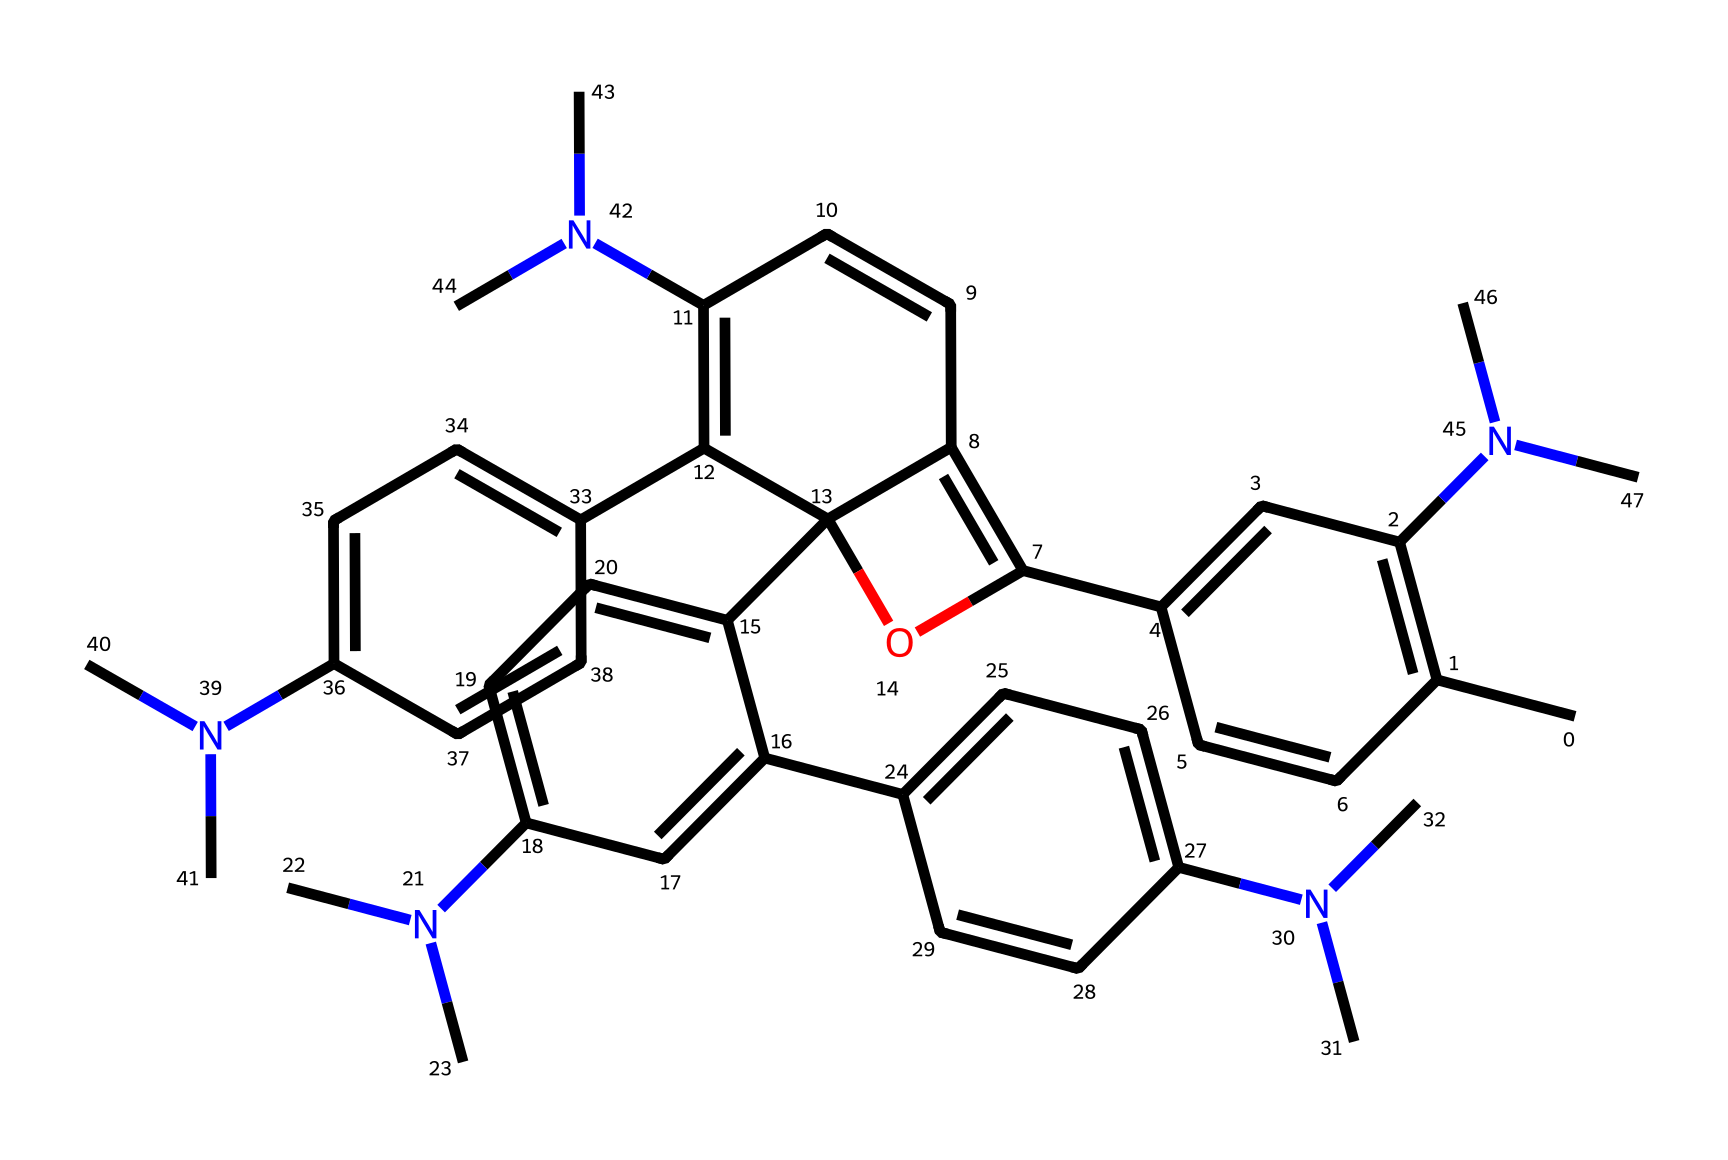What is the total number of nitrogen atoms in this compound? By examining the chemical structure, we can identify each nitrogen atom represented by the "N" symbol within the SMILES notation. In this case, by counting, we find that there are a total of six "N" present.
Answer: six What type of structure is primarily indicated by the multiple aromatic rings in this compound? The presence of multiple aromatic rings, each containing alternating single and double bonds represented in the SMILES, indicates that this compound likely exhibits polycyclic aromatic characteristics.
Answer: polycyclic aromatic How many hydroxyl (OH) groups are present in this compound? Looking closely at the structure and the representation, we can see that there is one "O" that corresponds to a hydroxyl group attached with a hydrogen atom (OH), indicating a single hydroxyl functionality.
Answer: one Does this compound likely exhibit photochromic properties? The presence of nitrogen atoms and a complex structure with multiple conjugated double bonds typically indicates a likelihood of photochromism; these arrangements facilitate electronic transitions upon light exposure.
Answer: yes How are the substituents affecting the compound's solubility in various solvents? The presence of many nitrogen groups, particularly in the form of dimethylamino groups (N(C)C), often enhances solubility in polar solvents, while the hydrophobic aromatic segments may favor non-polar solvents, indicating solubility depends largely on the solvent's nature.
Answer: varies by solvent What role do the aromatic rings play in the functionality of this compound as a smart window material? The aromatic rings contribute to the electronic structure that allows the compound to absorb specific wavelengths of light, facilitating its responsiveness to changes in light intensity, crucial for smart window capabilities.
Answer: light absorption What can be inferred about the thermal stability based on the compound's structure? The extensive conjugation and multiple nitrogen atoms suggest that this compound may have lower thermal stability compared to simpler structures, as conjugated systems can be susceptible to thermal degradation under prolonged heating.
Answer: lower stability 